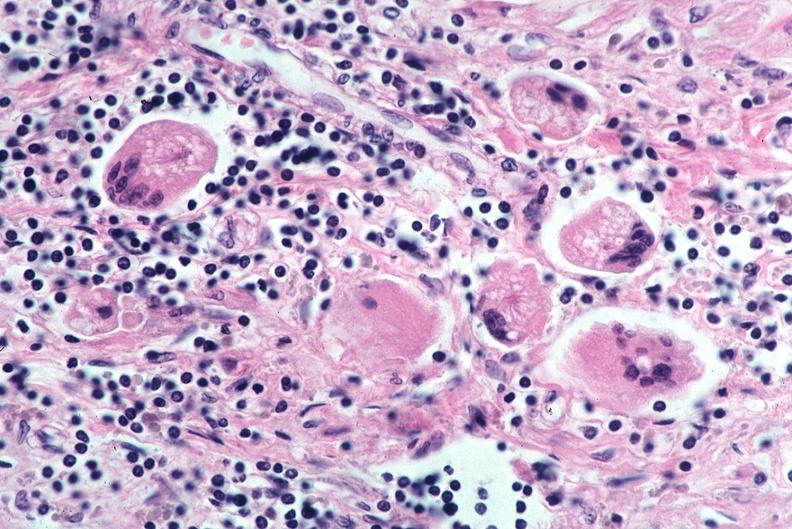does this image show lung, sarcoidosis, multinucleated giant cells with asteroid bodies?
Answer the question using a single word or phrase. Yes 